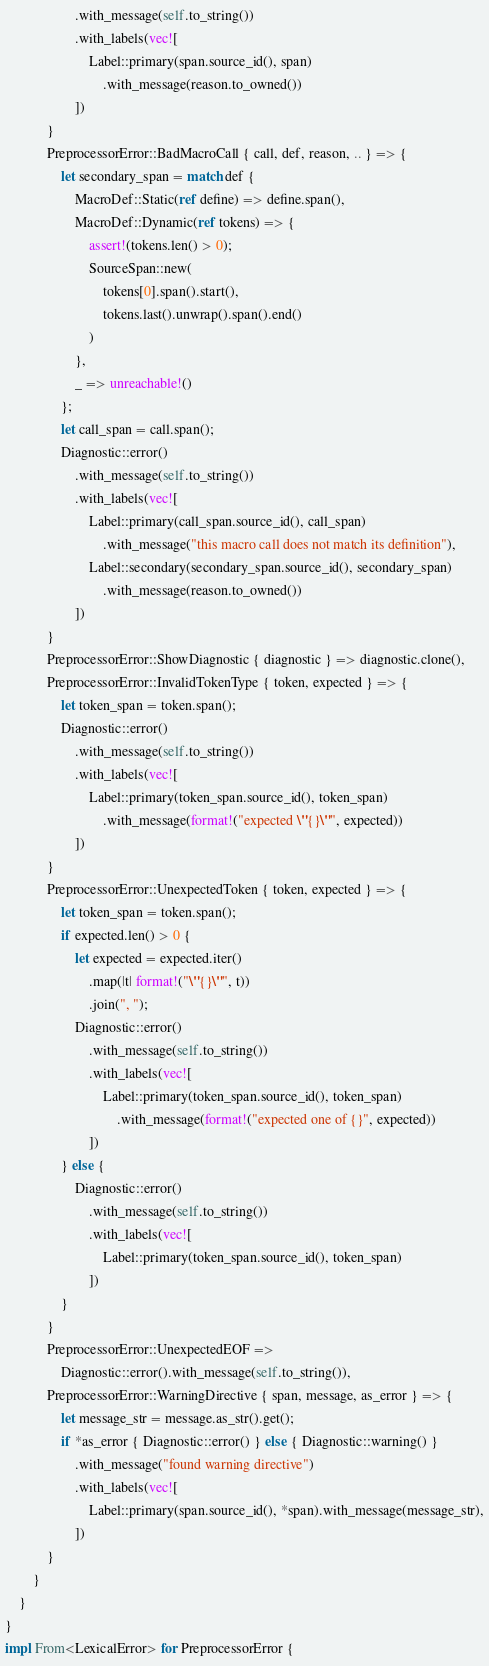Convert code to text. <code><loc_0><loc_0><loc_500><loc_500><_Rust_>                    .with_message(self.to_string())
                    .with_labels(vec![
                        Label::primary(span.source_id(), span)
                            .with_message(reason.to_owned())
                    ])
            }
            PreprocessorError::BadMacroCall { call, def, reason, .. } => {
                let secondary_span = match def {
                    MacroDef::Static(ref define) => define.span(),
                    MacroDef::Dynamic(ref tokens) => {
                        assert!(tokens.len() > 0);
                        SourceSpan::new(
                            tokens[0].span().start(),
                            tokens.last().unwrap().span().end()
                        )
                    },
                    _ => unreachable!()
                };
                let call_span = call.span();
                Diagnostic::error()
                    .with_message(self.to_string())
                    .with_labels(vec![
                        Label::primary(call_span.source_id(), call_span)
                            .with_message("this macro call does not match its definition"),
                        Label::secondary(secondary_span.source_id(), secondary_span)
                            .with_message(reason.to_owned())
                    ])
            }
            PreprocessorError::ShowDiagnostic { diagnostic } => diagnostic.clone(),
            PreprocessorError::InvalidTokenType { token, expected } => {
                let token_span = token.span();
                Diagnostic::error()
                    .with_message(self.to_string())
                    .with_labels(vec![
                        Label::primary(token_span.source_id(), token_span)
                            .with_message(format!("expected \"{}\"", expected))
                    ])
            }
            PreprocessorError::UnexpectedToken { token, expected } => {
                let token_span = token.span();
                if expected.len() > 0 {
                    let expected = expected.iter()
                        .map(|t| format!("\"{}\"", t))
                        .join(", ");
                    Diagnostic::error()
                        .with_message(self.to_string())
                        .with_labels(vec![
                            Label::primary(token_span.source_id(), token_span)
                                .with_message(format!("expected one of {}", expected))
                        ])
                } else {
                    Diagnostic::error()
                        .with_message(self.to_string())
                        .with_labels(vec![
                            Label::primary(token_span.source_id(), token_span)
                        ])
                }
            }
            PreprocessorError::UnexpectedEOF =>
                Diagnostic::error().with_message(self.to_string()),
            PreprocessorError::WarningDirective { span, message, as_error } => {
                let message_str = message.as_str().get();
                if *as_error { Diagnostic::error() } else { Diagnostic::warning() }
                    .with_message("found warning directive")
                    .with_labels(vec![
                        Label::primary(span.source_id(), *span).with_message(message_str),
                    ])
            }
        }
    }
}
impl From<LexicalError> for PreprocessorError {</code> 